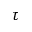Convert formula to latex. <formula><loc_0><loc_0><loc_500><loc_500>\tau</formula> 